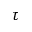Convert formula to latex. <formula><loc_0><loc_0><loc_500><loc_500>\tau</formula> 